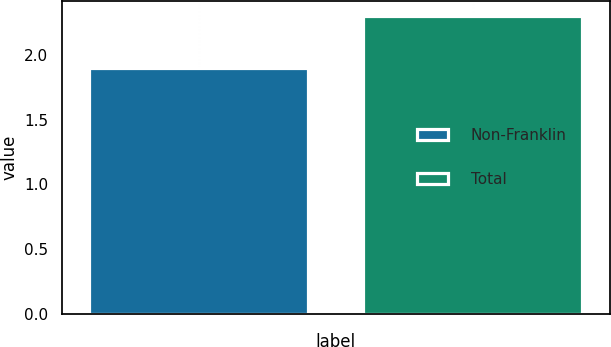<chart> <loc_0><loc_0><loc_500><loc_500><bar_chart><fcel>Non-Franklin<fcel>Total<nl><fcel>1.9<fcel>2.3<nl></chart> 